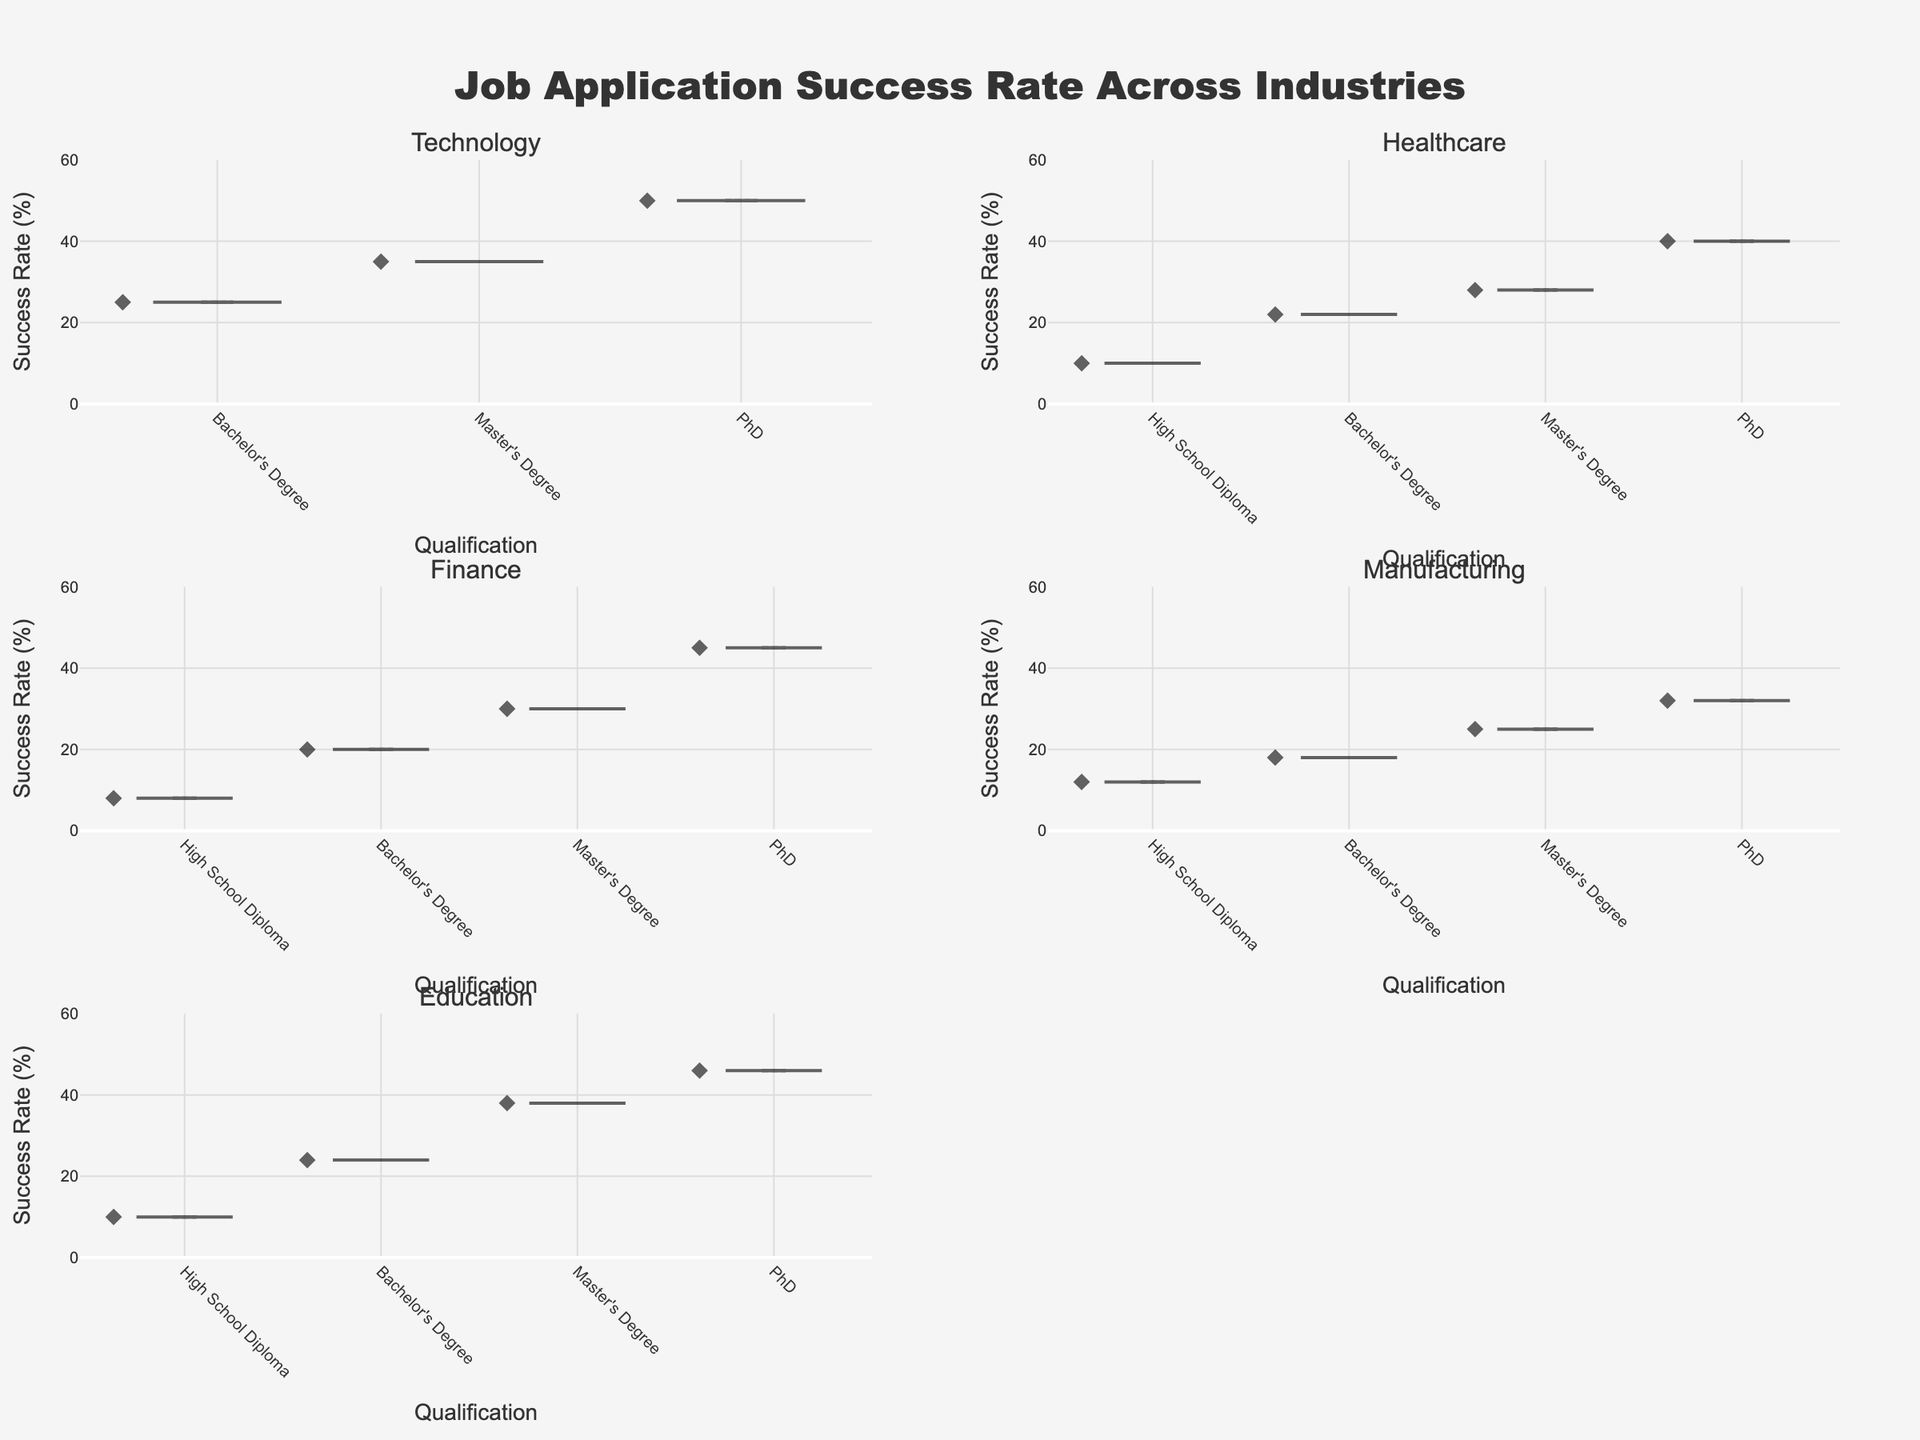What is the title of the figure? The title of the figure is displayed at the top-center of the plot. By looking at the top of the image, you can read the text "Job Application Success Rate Across Industries".
Answer: Job Application Success Rate Across Industries What are the qualifications labeled on the x-axis? The x-axis across different subplots shows labels for qualifications. By examining these labels, you will notice qualifications such as "High School Diploma", "Bachelor's Degree", "Master's Degree", and "PhD".
Answer: High School Diploma, Bachelor's Degree, Master's Degree, PhD Which industry has the highest job application success rate for PhD qualifications? To find out which industry has the highest success rate for PhD qualifications, refer to the peaks of the violins corresponding to the "PhD" label on the x-axis of each subplot. The "Technology" subplot reaches the highest value of 50%.
Answer: Technology What is the range of success rates for "Healthcare" across all qualifications? Examine the "Healthcare" subplot. The lowest point is 10% (High School Diploma), and the highest point is 40% (PhD), giving a range from 10% to 40%.
Answer: 10% to 40% Compare the success rates for Master's Degree in Finance and Healthcare. Which is higher? Observe the "Master's Degree" points in the "Finance" and "Healthcare" subplots. The success rate for Finance is 30%, while for Healthcare it's 28%.
Answer: Finance What is the difference in success rates between Bachelor's degree and PhD in Education? In the "Education" subplot, find "Bachelor's Degree" and "PhD". The success rates are 24% and 46% respectively. Subtract 24% from 46% to get the difference.
Answer: 22% Are there any industries where a PhD does not achieve the highest success rate compared to other qualifications? Look at the peak success rates for each qualification within each industry. In all subplots (Technology, Healthcare, Finance, Manufacturing, and Education), PhD achieves the highest success rate.
Answer: No What can you infer about the general trend of success rates as qualification level increases? By observing the rising peaks in each subplot from "High School Diploma" to "PhD", you can infer that higher qualifications generally lead to higher job application success rates in all industries.
Answer: Higher qualifications generally lead to higher success rates Is there any industry where the success rate for "High School Diploma" is more than 10%? Look at the "High School Diploma" points in each subplot. Only "Manufacturing" has a success rate of 12% for high school graduates, which is more than 10%.
Answer: Manufacturing What is the average success rate for all qualifications in the Technology industry? Add up the success rates for all qualifications in the Technology industry: 25% (Bachelor's Degree) + 35% (Master's Degree) + 50% (PhD). Divide this total by the number of qualifications (3) to get the average.
Answer: 36.67% 